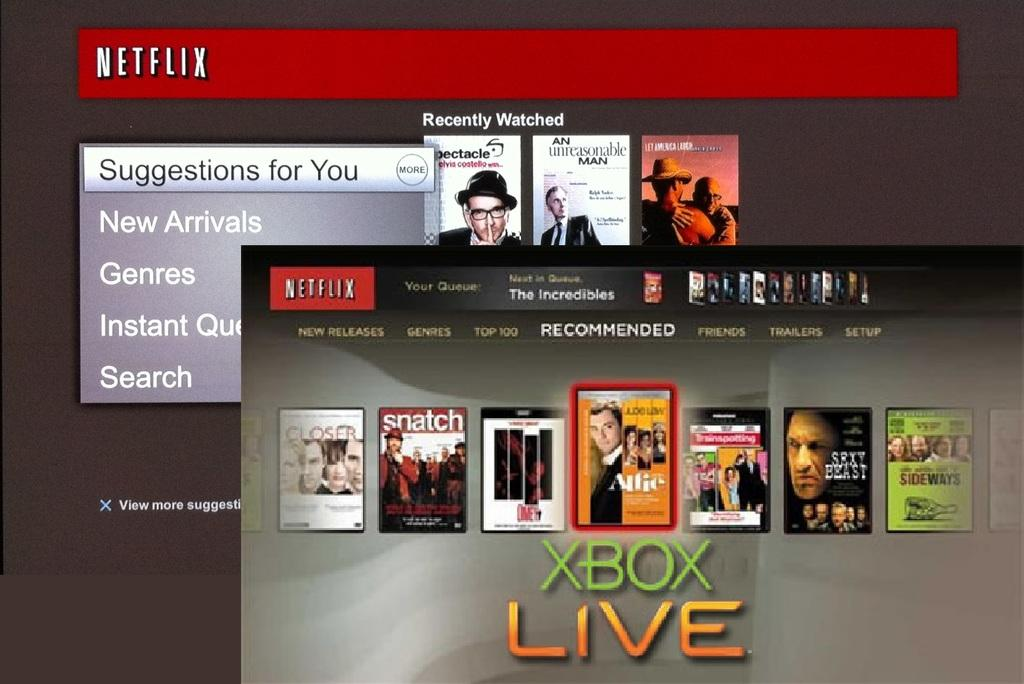<image>
Present a compact description of the photo's key features. A Netflix screen showing an ad for XBox Live. 